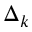<formula> <loc_0><loc_0><loc_500><loc_500>\Delta _ { k }</formula> 